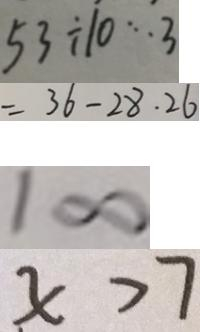<formula> <loc_0><loc_0><loc_500><loc_500>5 3 \div 1 0 \cdots 3 
 = 3 6 - 2 8 . 2 6 
 1 \infty 
 x > 7</formula> 